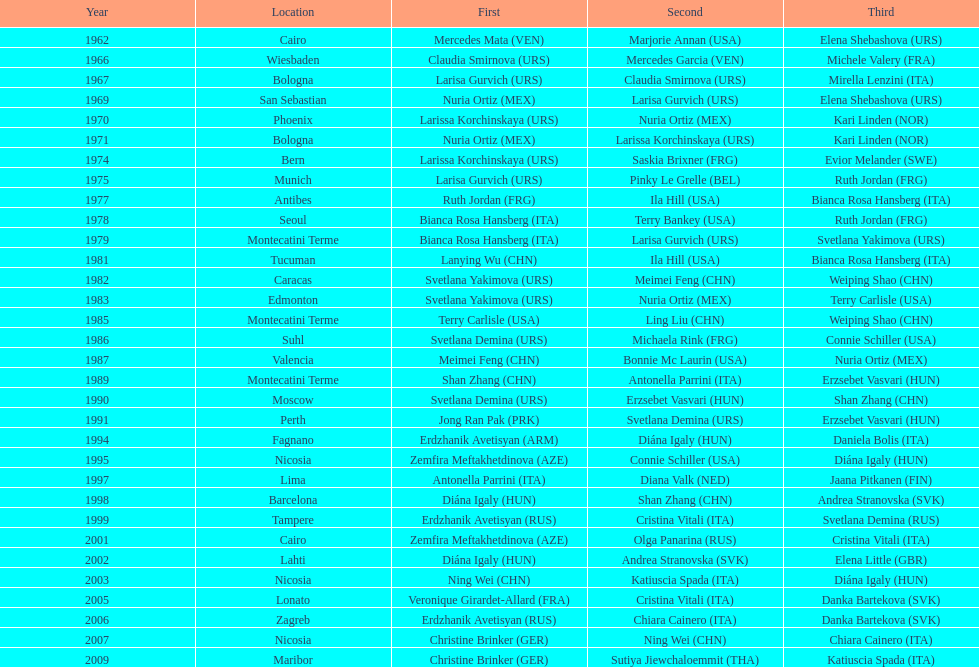What is the total amount of winnings for the united states in gold, silver and bronze? 9. Parse the full table. {'header': ['Year', 'Location', 'First', 'Second', 'Third'], 'rows': [['1962', 'Cairo', 'Mercedes Mata\xa0(VEN)', 'Marjorie Annan\xa0(USA)', 'Elena Shebashova\xa0(URS)'], ['1966', 'Wiesbaden', 'Claudia Smirnova\xa0(URS)', 'Mercedes Garcia\xa0(VEN)', 'Michele Valery\xa0(FRA)'], ['1967', 'Bologna', 'Larisa Gurvich\xa0(URS)', 'Claudia Smirnova\xa0(URS)', 'Mirella Lenzini\xa0(ITA)'], ['1969', 'San Sebastian', 'Nuria Ortiz\xa0(MEX)', 'Larisa Gurvich\xa0(URS)', 'Elena Shebashova\xa0(URS)'], ['1970', 'Phoenix', 'Larissa Korchinskaya\xa0(URS)', 'Nuria Ortiz\xa0(MEX)', 'Kari Linden\xa0(NOR)'], ['1971', 'Bologna', 'Nuria Ortiz\xa0(MEX)', 'Larissa Korchinskaya\xa0(URS)', 'Kari Linden\xa0(NOR)'], ['1974', 'Bern', 'Larissa Korchinskaya\xa0(URS)', 'Saskia Brixner\xa0(FRG)', 'Evior Melander\xa0(SWE)'], ['1975', 'Munich', 'Larisa Gurvich\xa0(URS)', 'Pinky Le Grelle\xa0(BEL)', 'Ruth Jordan\xa0(FRG)'], ['1977', 'Antibes', 'Ruth Jordan\xa0(FRG)', 'Ila Hill\xa0(USA)', 'Bianca Rosa Hansberg\xa0(ITA)'], ['1978', 'Seoul', 'Bianca Rosa Hansberg\xa0(ITA)', 'Terry Bankey\xa0(USA)', 'Ruth Jordan\xa0(FRG)'], ['1979', 'Montecatini Terme', 'Bianca Rosa Hansberg\xa0(ITA)', 'Larisa Gurvich\xa0(URS)', 'Svetlana Yakimova\xa0(URS)'], ['1981', 'Tucuman', 'Lanying Wu\xa0(CHN)', 'Ila Hill\xa0(USA)', 'Bianca Rosa Hansberg\xa0(ITA)'], ['1982', 'Caracas', 'Svetlana Yakimova\xa0(URS)', 'Meimei Feng\xa0(CHN)', 'Weiping Shao\xa0(CHN)'], ['1983', 'Edmonton', 'Svetlana Yakimova\xa0(URS)', 'Nuria Ortiz\xa0(MEX)', 'Terry Carlisle\xa0(USA)'], ['1985', 'Montecatini Terme', 'Terry Carlisle\xa0(USA)', 'Ling Liu\xa0(CHN)', 'Weiping Shao\xa0(CHN)'], ['1986', 'Suhl', 'Svetlana Demina\xa0(URS)', 'Michaela Rink\xa0(FRG)', 'Connie Schiller\xa0(USA)'], ['1987', 'Valencia', 'Meimei Feng\xa0(CHN)', 'Bonnie Mc Laurin\xa0(USA)', 'Nuria Ortiz\xa0(MEX)'], ['1989', 'Montecatini Terme', 'Shan Zhang\xa0(CHN)', 'Antonella Parrini\xa0(ITA)', 'Erzsebet Vasvari\xa0(HUN)'], ['1990', 'Moscow', 'Svetlana Demina\xa0(URS)', 'Erzsebet Vasvari\xa0(HUN)', 'Shan Zhang\xa0(CHN)'], ['1991', 'Perth', 'Jong Ran Pak\xa0(PRK)', 'Svetlana Demina\xa0(URS)', 'Erzsebet Vasvari\xa0(HUN)'], ['1994', 'Fagnano', 'Erdzhanik Avetisyan\xa0(ARM)', 'Diána Igaly\xa0(HUN)', 'Daniela Bolis\xa0(ITA)'], ['1995', 'Nicosia', 'Zemfira Meftakhetdinova\xa0(AZE)', 'Connie Schiller\xa0(USA)', 'Diána Igaly\xa0(HUN)'], ['1997', 'Lima', 'Antonella Parrini\xa0(ITA)', 'Diana Valk\xa0(NED)', 'Jaana Pitkanen\xa0(FIN)'], ['1998', 'Barcelona', 'Diána Igaly\xa0(HUN)', 'Shan Zhang\xa0(CHN)', 'Andrea Stranovska\xa0(SVK)'], ['1999', 'Tampere', 'Erdzhanik Avetisyan\xa0(RUS)', 'Cristina Vitali\xa0(ITA)', 'Svetlana Demina\xa0(RUS)'], ['2001', 'Cairo', 'Zemfira Meftakhetdinova\xa0(AZE)', 'Olga Panarina\xa0(RUS)', 'Cristina Vitali\xa0(ITA)'], ['2002', 'Lahti', 'Diána Igaly\xa0(HUN)', 'Andrea Stranovska\xa0(SVK)', 'Elena Little\xa0(GBR)'], ['2003', 'Nicosia', 'Ning Wei\xa0(CHN)', 'Katiuscia Spada\xa0(ITA)', 'Diána Igaly\xa0(HUN)'], ['2005', 'Lonato', 'Veronique Girardet-Allard\xa0(FRA)', 'Cristina Vitali\xa0(ITA)', 'Danka Bartekova\xa0(SVK)'], ['2006', 'Zagreb', 'Erdzhanik Avetisyan\xa0(RUS)', 'Chiara Cainero\xa0(ITA)', 'Danka Bartekova\xa0(SVK)'], ['2007', 'Nicosia', 'Christine Brinker\xa0(GER)', 'Ning Wei\xa0(CHN)', 'Chiara Cainero\xa0(ITA)'], ['2009', 'Maribor', 'Christine Brinker\xa0(GER)', 'Sutiya Jiewchaloemmit\xa0(THA)', 'Katiuscia Spada\xa0(ITA)']]} 